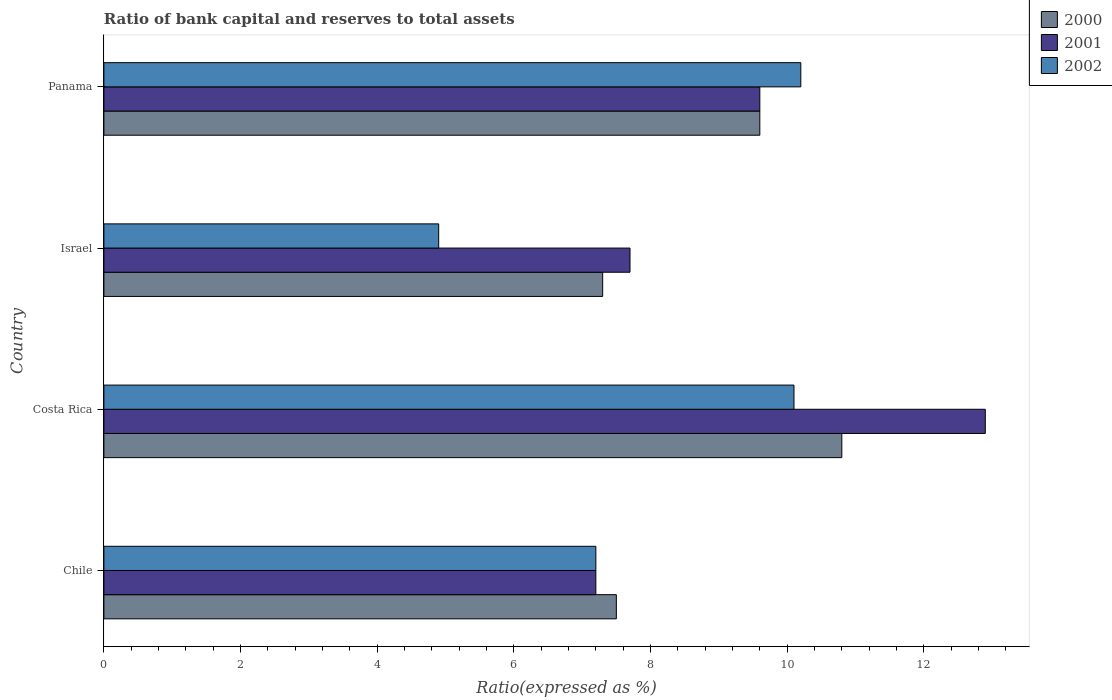Are the number of bars per tick equal to the number of legend labels?
Provide a succinct answer. Yes. How many bars are there on the 1st tick from the bottom?
Keep it short and to the point. 3. What is the label of the 1st group of bars from the top?
Provide a short and direct response. Panama. In how many cases, is the number of bars for a given country not equal to the number of legend labels?
Your answer should be very brief. 0. What is the ratio of bank capital and reserves to total assets in 2000 in Chile?
Make the answer very short. 7.5. Across all countries, what is the minimum ratio of bank capital and reserves to total assets in 2000?
Your response must be concise. 7.3. In which country was the ratio of bank capital and reserves to total assets in 2002 minimum?
Provide a succinct answer. Israel. What is the total ratio of bank capital and reserves to total assets in 2001 in the graph?
Offer a very short reply. 37.4. What is the difference between the ratio of bank capital and reserves to total assets in 2002 in Chile and that in Costa Rica?
Offer a very short reply. -2.9. What is the difference between the ratio of bank capital and reserves to total assets in 2000 in Chile and the ratio of bank capital and reserves to total assets in 2002 in Costa Rica?
Your response must be concise. -2.6. What is the average ratio of bank capital and reserves to total assets in 2001 per country?
Provide a succinct answer. 9.35. What is the difference between the ratio of bank capital and reserves to total assets in 2002 and ratio of bank capital and reserves to total assets in 2000 in Costa Rica?
Keep it short and to the point. -0.7. In how many countries, is the ratio of bank capital and reserves to total assets in 2002 greater than 12.8 %?
Your answer should be compact. 0. What is the ratio of the ratio of bank capital and reserves to total assets in 2000 in Chile to that in Panama?
Make the answer very short. 0.78. Is the ratio of bank capital and reserves to total assets in 2001 in Israel less than that in Panama?
Offer a very short reply. Yes. Is the difference between the ratio of bank capital and reserves to total assets in 2002 in Chile and Panama greater than the difference between the ratio of bank capital and reserves to total assets in 2000 in Chile and Panama?
Provide a short and direct response. No. What is the difference between the highest and the second highest ratio of bank capital and reserves to total assets in 2002?
Give a very brief answer. 0.1. What is the difference between the highest and the lowest ratio of bank capital and reserves to total assets in 2002?
Your answer should be very brief. 5.3. In how many countries, is the ratio of bank capital and reserves to total assets in 2000 greater than the average ratio of bank capital and reserves to total assets in 2000 taken over all countries?
Make the answer very short. 2. Is the sum of the ratio of bank capital and reserves to total assets in 2000 in Chile and Costa Rica greater than the maximum ratio of bank capital and reserves to total assets in 2002 across all countries?
Give a very brief answer. Yes. What does the 3rd bar from the bottom in Panama represents?
Your answer should be compact. 2002. Is it the case that in every country, the sum of the ratio of bank capital and reserves to total assets in 2001 and ratio of bank capital and reserves to total assets in 2002 is greater than the ratio of bank capital and reserves to total assets in 2000?
Offer a very short reply. Yes. How many bars are there?
Offer a very short reply. 12. Are the values on the major ticks of X-axis written in scientific E-notation?
Provide a succinct answer. No. Where does the legend appear in the graph?
Your answer should be very brief. Top right. How are the legend labels stacked?
Give a very brief answer. Vertical. What is the title of the graph?
Provide a succinct answer. Ratio of bank capital and reserves to total assets. What is the label or title of the X-axis?
Provide a short and direct response. Ratio(expressed as %). What is the Ratio(expressed as %) of 2001 in Chile?
Give a very brief answer. 7.2. What is the Ratio(expressed as %) of 2002 in Chile?
Provide a succinct answer. 7.2. What is the Ratio(expressed as %) in 2000 in Costa Rica?
Make the answer very short. 10.8. What is the Ratio(expressed as %) of 2000 in Israel?
Ensure brevity in your answer.  7.3. What is the Ratio(expressed as %) in 2002 in Israel?
Offer a terse response. 4.9. What is the Ratio(expressed as %) in 2001 in Panama?
Provide a succinct answer. 9.6. What is the Ratio(expressed as %) in 2002 in Panama?
Provide a short and direct response. 10.2. Across all countries, what is the maximum Ratio(expressed as %) in 2000?
Your answer should be very brief. 10.8. Across all countries, what is the maximum Ratio(expressed as %) of 2001?
Make the answer very short. 12.9. Across all countries, what is the minimum Ratio(expressed as %) in 2000?
Keep it short and to the point. 7.3. What is the total Ratio(expressed as %) in 2000 in the graph?
Ensure brevity in your answer.  35.2. What is the total Ratio(expressed as %) of 2001 in the graph?
Make the answer very short. 37.4. What is the total Ratio(expressed as %) of 2002 in the graph?
Offer a terse response. 32.4. What is the difference between the Ratio(expressed as %) in 2001 in Chile and that in Costa Rica?
Give a very brief answer. -5.7. What is the difference between the Ratio(expressed as %) in 2001 in Chile and that in Israel?
Offer a very short reply. -0.5. What is the difference between the Ratio(expressed as %) in 2002 in Chile and that in Israel?
Offer a very short reply. 2.3. What is the difference between the Ratio(expressed as %) of 2000 in Chile and that in Panama?
Keep it short and to the point. -2.1. What is the difference between the Ratio(expressed as %) in 2000 in Costa Rica and that in Israel?
Ensure brevity in your answer.  3.5. What is the difference between the Ratio(expressed as %) in 2000 in Costa Rica and that in Panama?
Your answer should be compact. 1.2. What is the difference between the Ratio(expressed as %) of 2000 in Israel and that in Panama?
Provide a short and direct response. -2.3. What is the difference between the Ratio(expressed as %) of 2000 in Chile and the Ratio(expressed as %) of 2002 in Costa Rica?
Provide a short and direct response. -2.6. What is the difference between the Ratio(expressed as %) in 2000 in Chile and the Ratio(expressed as %) in 2001 in Panama?
Ensure brevity in your answer.  -2.1. What is the difference between the Ratio(expressed as %) of 2000 in Chile and the Ratio(expressed as %) of 2002 in Panama?
Provide a succinct answer. -2.7. What is the difference between the Ratio(expressed as %) in 2001 in Chile and the Ratio(expressed as %) in 2002 in Panama?
Ensure brevity in your answer.  -3. What is the difference between the Ratio(expressed as %) of 2000 in Costa Rica and the Ratio(expressed as %) of 2002 in Israel?
Offer a very short reply. 5.9. What is the difference between the Ratio(expressed as %) of 2001 in Costa Rica and the Ratio(expressed as %) of 2002 in Israel?
Provide a succinct answer. 8. What is the difference between the Ratio(expressed as %) of 2000 in Costa Rica and the Ratio(expressed as %) of 2001 in Panama?
Give a very brief answer. 1.2. What is the difference between the Ratio(expressed as %) in 2000 in Costa Rica and the Ratio(expressed as %) in 2002 in Panama?
Your response must be concise. 0.6. What is the difference between the Ratio(expressed as %) in 2000 in Israel and the Ratio(expressed as %) in 2001 in Panama?
Give a very brief answer. -2.3. What is the difference between the Ratio(expressed as %) of 2000 in Israel and the Ratio(expressed as %) of 2002 in Panama?
Give a very brief answer. -2.9. What is the difference between the Ratio(expressed as %) of 2001 in Israel and the Ratio(expressed as %) of 2002 in Panama?
Keep it short and to the point. -2.5. What is the average Ratio(expressed as %) in 2000 per country?
Your answer should be very brief. 8.8. What is the average Ratio(expressed as %) of 2001 per country?
Offer a terse response. 9.35. What is the average Ratio(expressed as %) of 2002 per country?
Keep it short and to the point. 8.1. What is the difference between the Ratio(expressed as %) of 2000 and Ratio(expressed as %) of 2001 in Chile?
Make the answer very short. 0.3. What is the difference between the Ratio(expressed as %) of 2000 and Ratio(expressed as %) of 2002 in Chile?
Provide a short and direct response. 0.3. What is the difference between the Ratio(expressed as %) in 2001 and Ratio(expressed as %) in 2002 in Chile?
Your answer should be compact. 0. What is the difference between the Ratio(expressed as %) in 2000 and Ratio(expressed as %) in 2002 in Costa Rica?
Your answer should be very brief. 0.7. What is the difference between the Ratio(expressed as %) of 2000 and Ratio(expressed as %) of 2001 in Israel?
Make the answer very short. -0.4. What is the difference between the Ratio(expressed as %) in 2000 and Ratio(expressed as %) in 2001 in Panama?
Provide a succinct answer. 0. What is the difference between the Ratio(expressed as %) in 2000 and Ratio(expressed as %) in 2002 in Panama?
Provide a succinct answer. -0.6. What is the difference between the Ratio(expressed as %) in 2001 and Ratio(expressed as %) in 2002 in Panama?
Keep it short and to the point. -0.6. What is the ratio of the Ratio(expressed as %) of 2000 in Chile to that in Costa Rica?
Make the answer very short. 0.69. What is the ratio of the Ratio(expressed as %) in 2001 in Chile to that in Costa Rica?
Your answer should be compact. 0.56. What is the ratio of the Ratio(expressed as %) in 2002 in Chile to that in Costa Rica?
Keep it short and to the point. 0.71. What is the ratio of the Ratio(expressed as %) of 2000 in Chile to that in Israel?
Keep it short and to the point. 1.03. What is the ratio of the Ratio(expressed as %) of 2001 in Chile to that in Israel?
Provide a succinct answer. 0.94. What is the ratio of the Ratio(expressed as %) of 2002 in Chile to that in Israel?
Keep it short and to the point. 1.47. What is the ratio of the Ratio(expressed as %) in 2000 in Chile to that in Panama?
Make the answer very short. 0.78. What is the ratio of the Ratio(expressed as %) in 2002 in Chile to that in Panama?
Offer a terse response. 0.71. What is the ratio of the Ratio(expressed as %) of 2000 in Costa Rica to that in Israel?
Your response must be concise. 1.48. What is the ratio of the Ratio(expressed as %) in 2001 in Costa Rica to that in Israel?
Your answer should be very brief. 1.68. What is the ratio of the Ratio(expressed as %) of 2002 in Costa Rica to that in Israel?
Your response must be concise. 2.06. What is the ratio of the Ratio(expressed as %) in 2001 in Costa Rica to that in Panama?
Ensure brevity in your answer.  1.34. What is the ratio of the Ratio(expressed as %) in 2002 in Costa Rica to that in Panama?
Offer a very short reply. 0.99. What is the ratio of the Ratio(expressed as %) of 2000 in Israel to that in Panama?
Ensure brevity in your answer.  0.76. What is the ratio of the Ratio(expressed as %) in 2001 in Israel to that in Panama?
Your answer should be compact. 0.8. What is the ratio of the Ratio(expressed as %) in 2002 in Israel to that in Panama?
Keep it short and to the point. 0.48. What is the difference between the highest and the second highest Ratio(expressed as %) of 2002?
Offer a terse response. 0.1. What is the difference between the highest and the lowest Ratio(expressed as %) of 2000?
Keep it short and to the point. 3.5. 